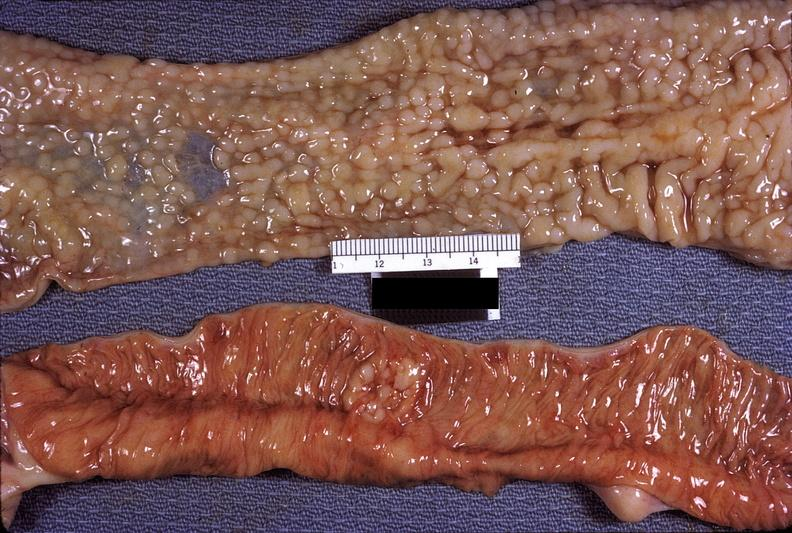does hand show small intestine, hodgkins lymphosarcoma?
Answer the question using a single word or phrase. No 